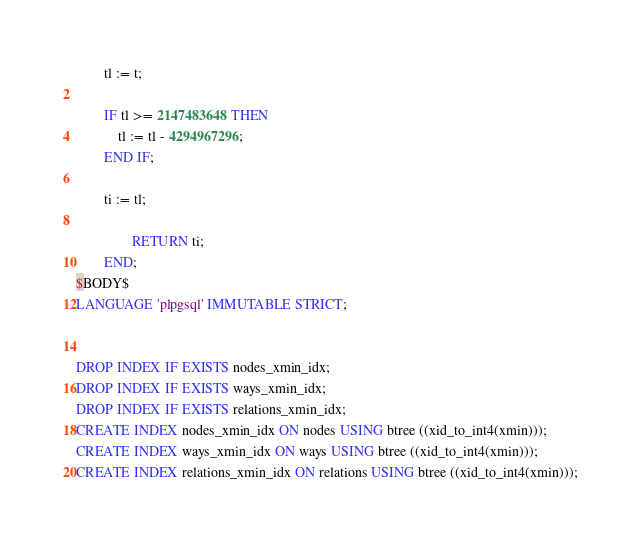Convert code to text. <code><loc_0><loc_0><loc_500><loc_500><_SQL_>		tl := t;

		IF tl >= 2147483648 THEN
			tl := tl - 4294967296;
		END IF;
		
		ti := tl;
		
                RETURN ti;
        END;
$BODY$
LANGUAGE 'plpgsql' IMMUTABLE STRICT;


DROP INDEX IF EXISTS nodes_xmin_idx;
DROP INDEX IF EXISTS ways_xmin_idx;
DROP INDEX IF EXISTS relations_xmin_idx;
CREATE INDEX nodes_xmin_idx ON nodes USING btree ((xid_to_int4(xmin)));
CREATE INDEX ways_xmin_idx ON ways USING btree ((xid_to_int4(xmin)));
CREATE INDEX relations_xmin_idx ON relations USING btree ((xid_to_int4(xmin)));
</code> 